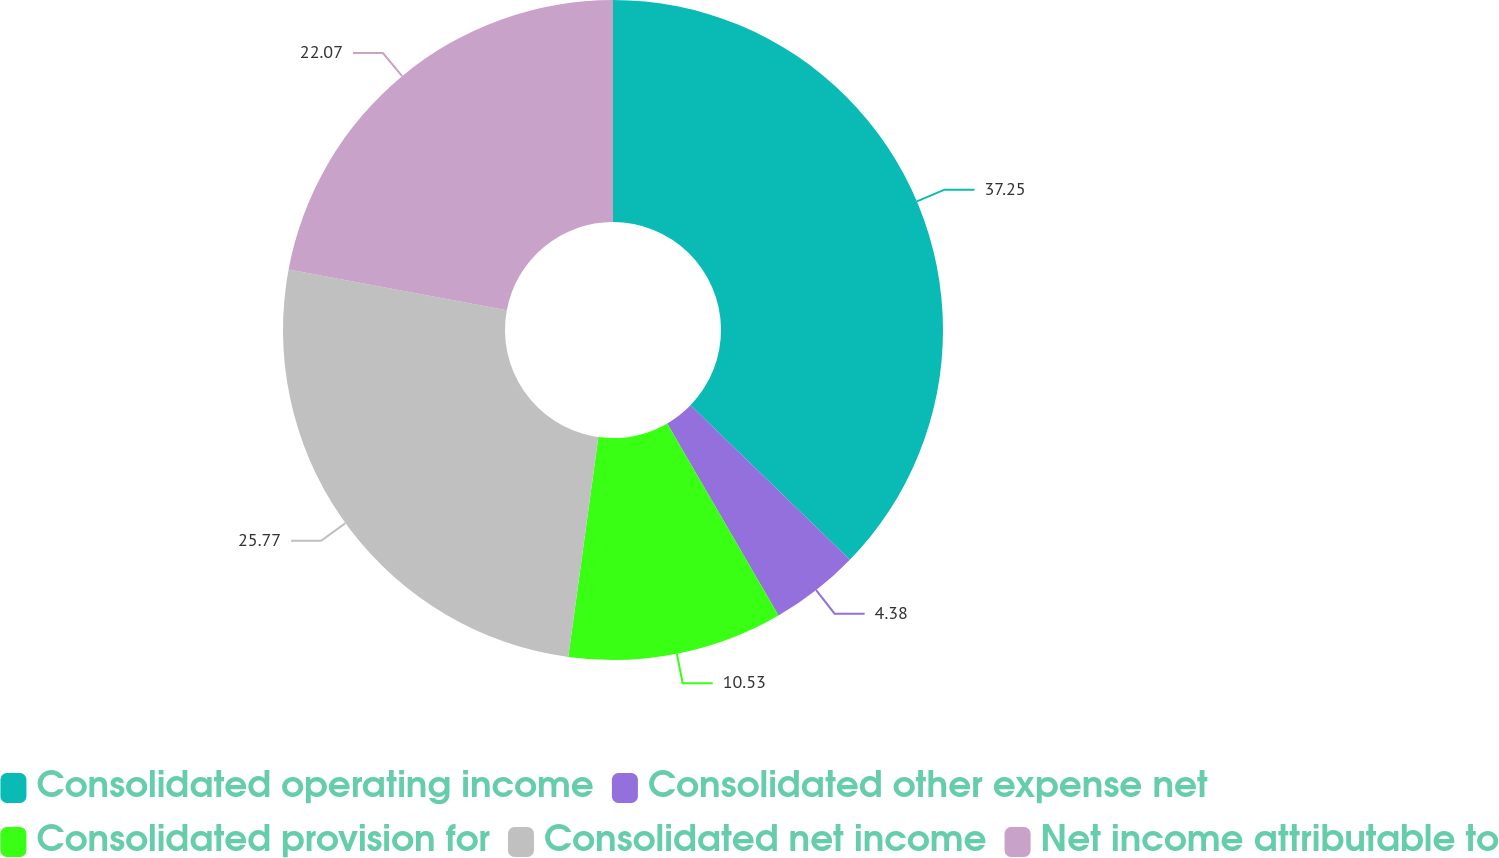Convert chart to OTSL. <chart><loc_0><loc_0><loc_500><loc_500><pie_chart><fcel>Consolidated operating income<fcel>Consolidated other expense net<fcel>Consolidated provision for<fcel>Consolidated net income<fcel>Net income attributable to<nl><fcel>37.26%<fcel>4.38%<fcel>10.53%<fcel>25.77%<fcel>22.07%<nl></chart> 